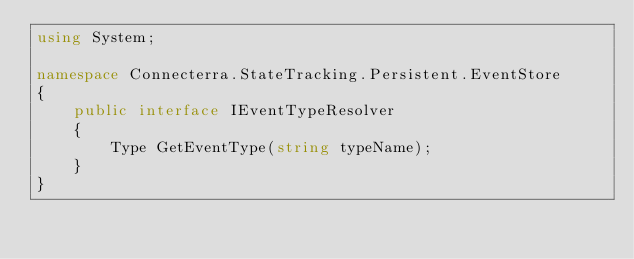<code> <loc_0><loc_0><loc_500><loc_500><_C#_>using System;

namespace Connecterra.StateTracking.Persistent.EventStore
{
    public interface IEventTypeResolver
    {
        Type GetEventType(string typeName);
    }
}</code> 